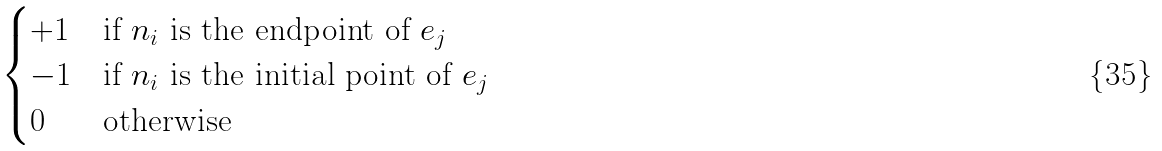<formula> <loc_0><loc_0><loc_500><loc_500>\begin{cases} + 1 & \text {if $n_{i}$ is the endpoint of $e_{j}$} \\ - 1 & \text {if $n_{i}$ is the initial point of $e_{j}$} \\ 0 & \text {otherwise} \end{cases}</formula> 